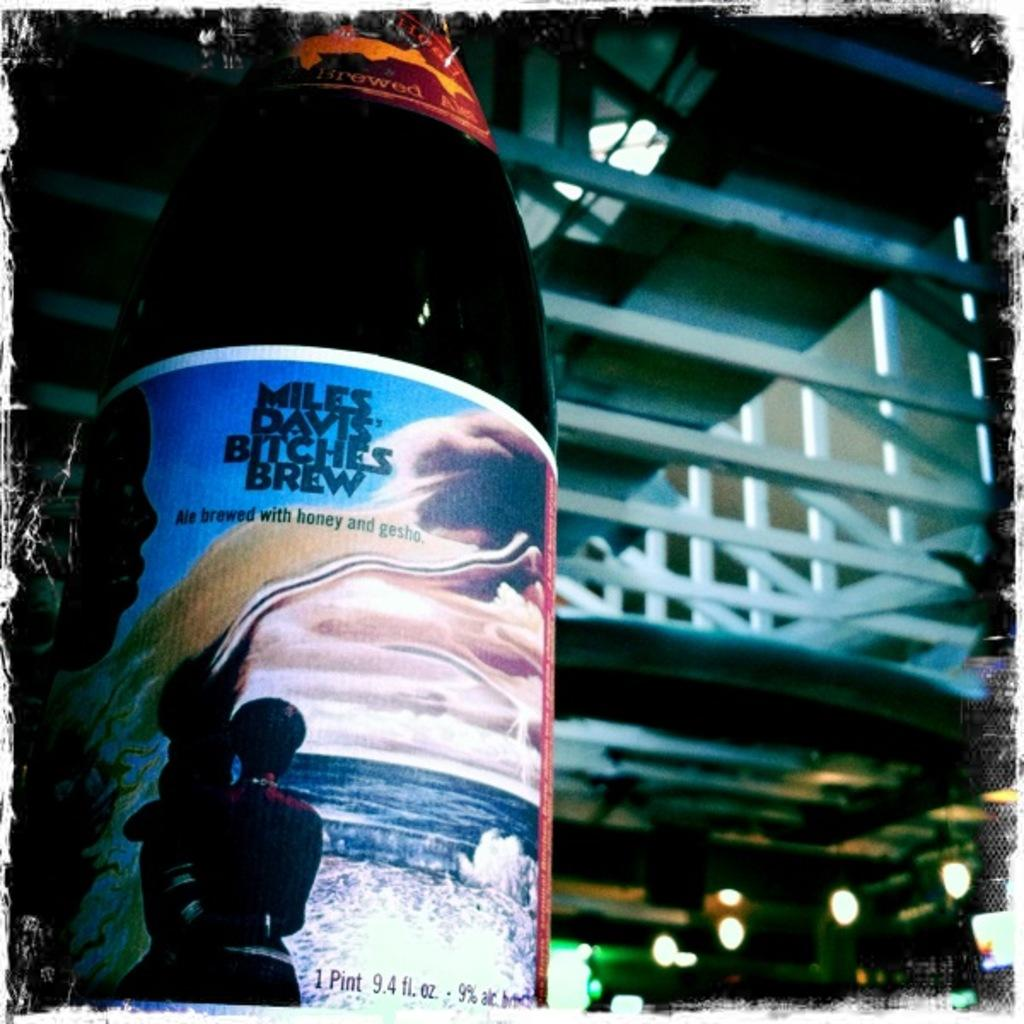What object can be seen in the image? There is a bottle in the image. What can be seen in the distance in the image? There is a building in the background of the image. What else is visible in the background of the image? There are lights visible in the background of the image. What letter is hanging on the hook in the image? There is no hook or letter present in the image. 